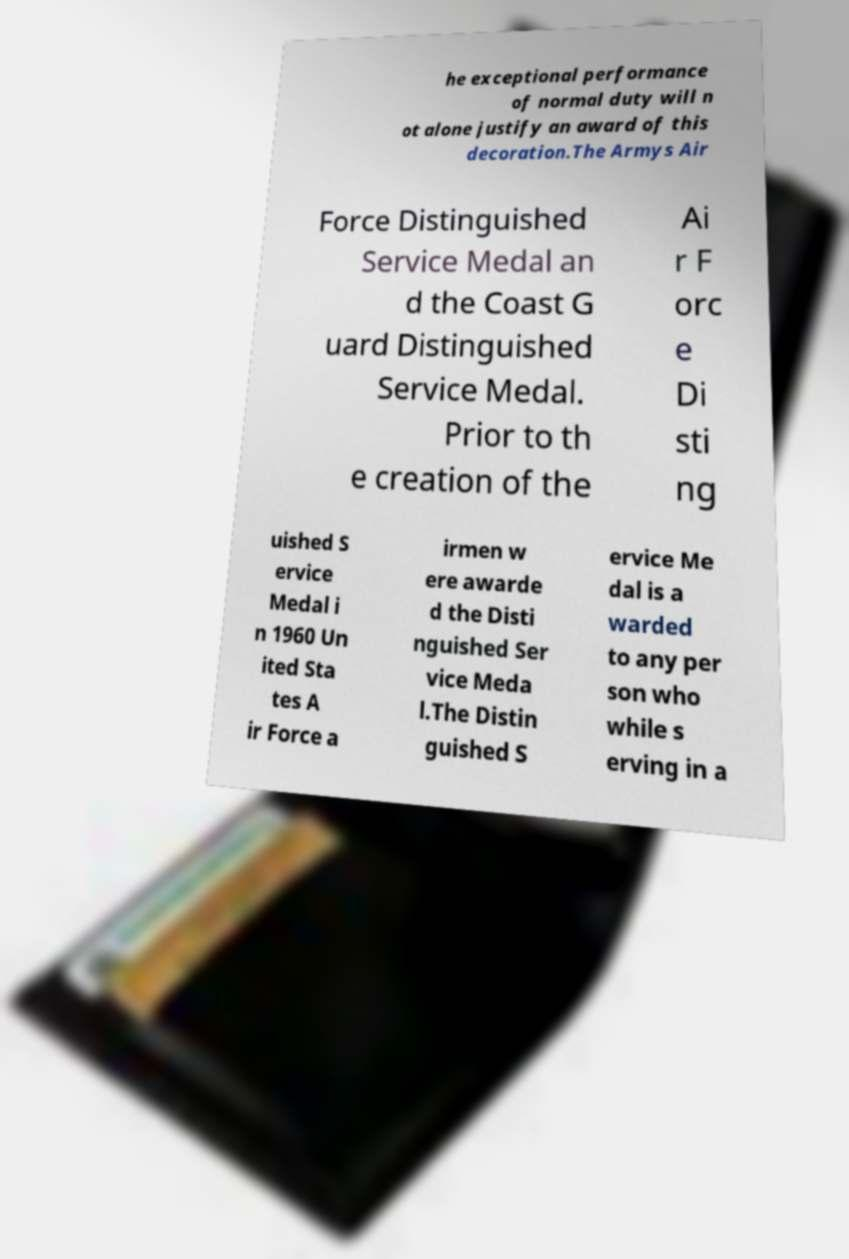What messages or text are displayed in this image? I need them in a readable, typed format. he exceptional performance of normal duty will n ot alone justify an award of this decoration.The Armys Air Force Distinguished Service Medal an d the Coast G uard Distinguished Service Medal. Prior to th e creation of the Ai r F orc e Di sti ng uished S ervice Medal i n 1960 Un ited Sta tes A ir Force a irmen w ere awarde d the Disti nguished Ser vice Meda l.The Distin guished S ervice Me dal is a warded to any per son who while s erving in a 